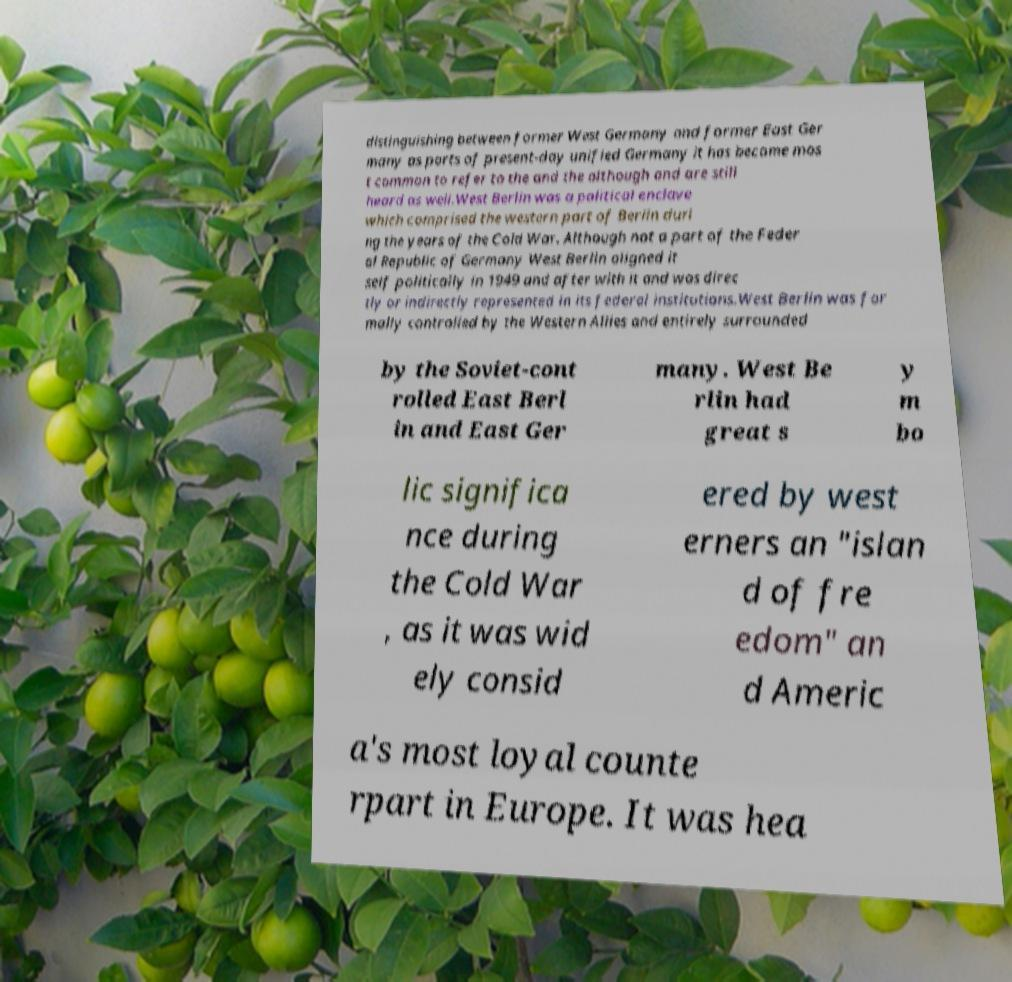What messages or text are displayed in this image? I need them in a readable, typed format. distinguishing between former West Germany and former East Ger many as parts of present-day unified Germany it has become mos t common to refer to the and the although and are still heard as well.West Berlin was a political enclave which comprised the western part of Berlin duri ng the years of the Cold War. Although not a part of the Feder al Republic of Germany West Berlin aligned it self politically in 1949 and after with it and was direc tly or indirectly represented in its federal institutions.West Berlin was for mally controlled by the Western Allies and entirely surrounded by the Soviet-cont rolled East Berl in and East Ger many. West Be rlin had great s y m bo lic significa nce during the Cold War , as it was wid ely consid ered by west erners an "islan d of fre edom" an d Americ a's most loyal counte rpart in Europe. It was hea 